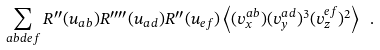Convert formula to latex. <formula><loc_0><loc_0><loc_500><loc_500>\sum _ { a b d e f } R ^ { \prime \prime } ( u _ { a b } ) R ^ { \prime \prime \prime \prime } ( u _ { a d } ) R ^ { \prime \prime } ( u _ { e f } ) \left < ( v ^ { a b } _ { x } ) ( v ^ { a d } _ { y } ) ^ { 3 } ( v ^ { e f } _ { z } ) ^ { 2 } \right > \ .</formula> 